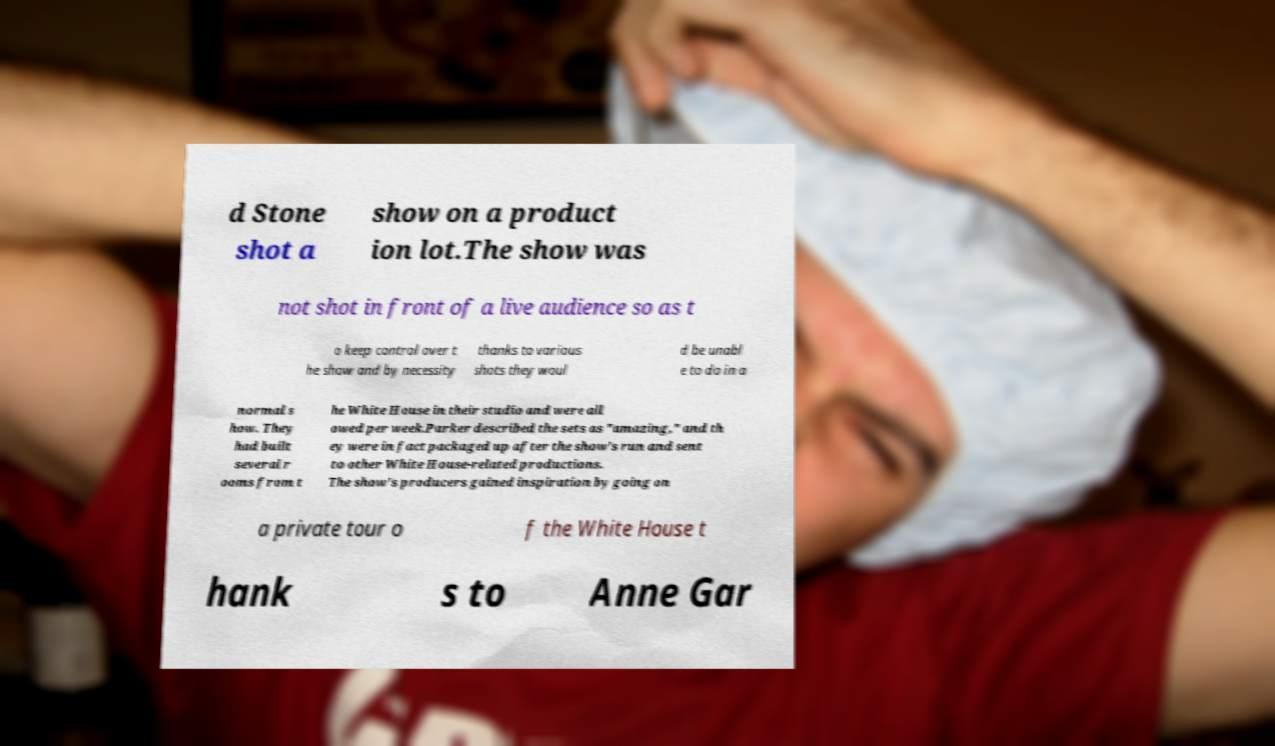Please identify and transcribe the text found in this image. d Stone shot a show on a product ion lot.The show was not shot in front of a live audience so as t o keep control over t he show and by necessity thanks to various shots they woul d be unabl e to do in a normal s how. They had built several r ooms from t he White House in their studio and were all owed per week.Parker described the sets as "amazing," and th ey were in fact packaged up after the show's run and sent to other White House-related productions. The show's producers gained inspiration by going on a private tour o f the White House t hank s to Anne Gar 